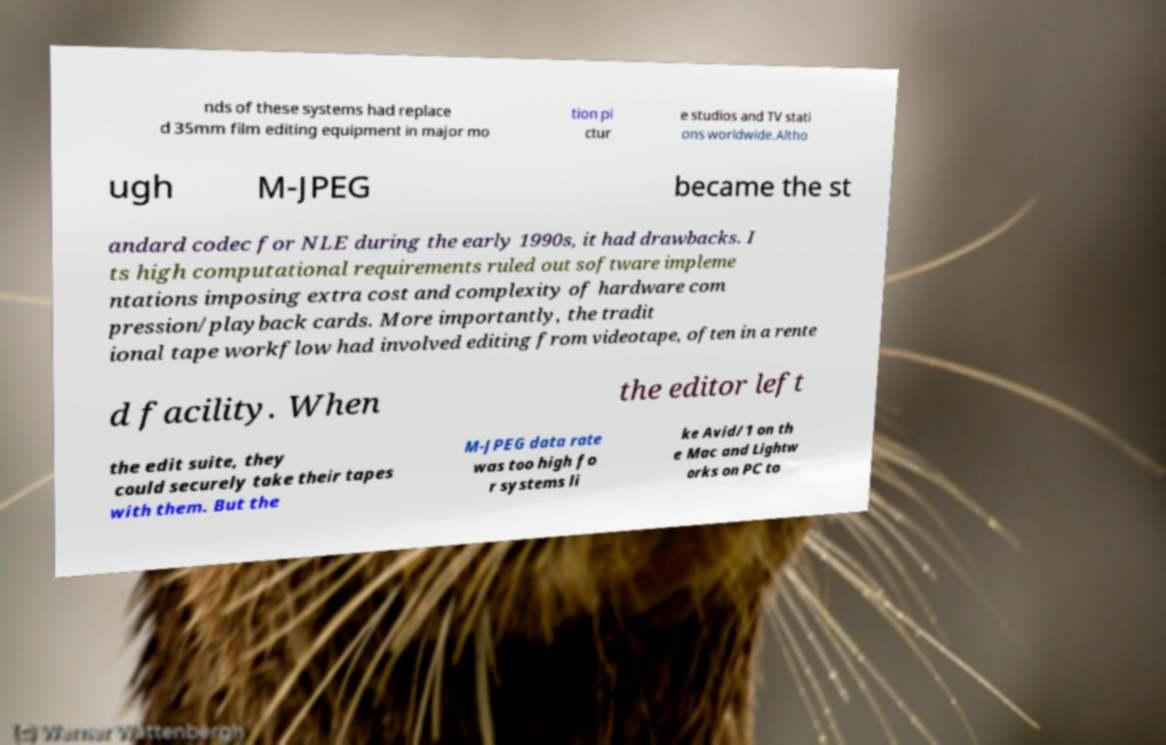Can you accurately transcribe the text from the provided image for me? nds of these systems had replace d 35mm film editing equipment in major mo tion pi ctur e studios and TV stati ons worldwide.Altho ugh M-JPEG became the st andard codec for NLE during the early 1990s, it had drawbacks. I ts high computational requirements ruled out software impleme ntations imposing extra cost and complexity of hardware com pression/playback cards. More importantly, the tradit ional tape workflow had involved editing from videotape, often in a rente d facility. When the editor left the edit suite, they could securely take their tapes with them. But the M-JPEG data rate was too high fo r systems li ke Avid/1 on th e Mac and Lightw orks on PC to 